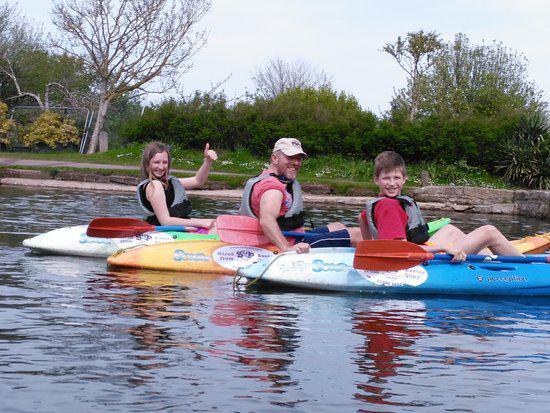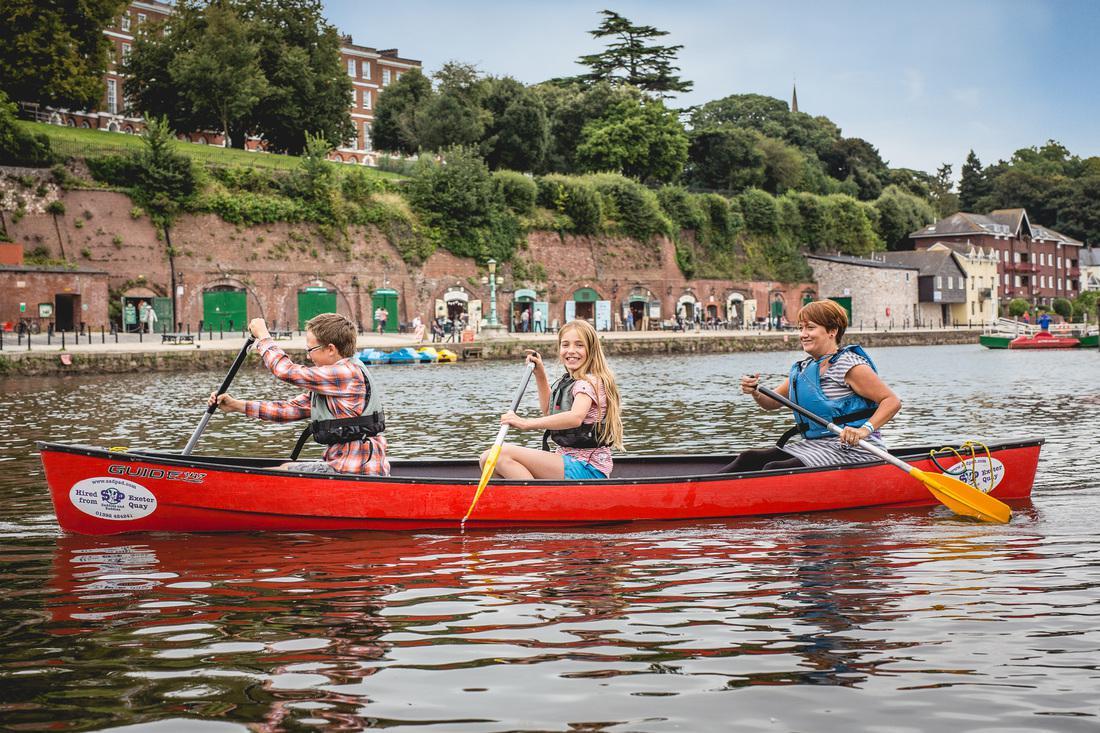The first image is the image on the left, the second image is the image on the right. Considering the images on both sides, is "Three adults paddle a single canoe though the water in the image on the right." valid? Answer yes or no. Yes. The first image is the image on the left, the second image is the image on the right. Analyze the images presented: Is the assertion "Three people ride a red canoe horizontally across the right image." valid? Answer yes or no. Yes. 